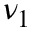<formula> <loc_0><loc_0><loc_500><loc_500>\nu _ { 1 }</formula> 